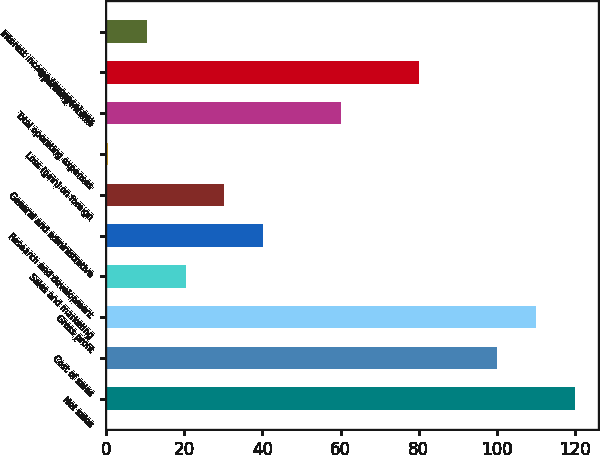Convert chart to OTSL. <chart><loc_0><loc_0><loc_500><loc_500><bar_chart><fcel>Net sales<fcel>Cost of sales<fcel>Gross profit<fcel>Sales and marketing<fcel>Research and development<fcel>General and administrative<fcel>Loss (gain) on foreign<fcel>Total operating expenses<fcel>Operating income<fcel>Interest income (expense) net<nl><fcel>119.92<fcel>100<fcel>109.96<fcel>20.32<fcel>40.24<fcel>30.28<fcel>0.4<fcel>60.16<fcel>80.08<fcel>10.36<nl></chart> 